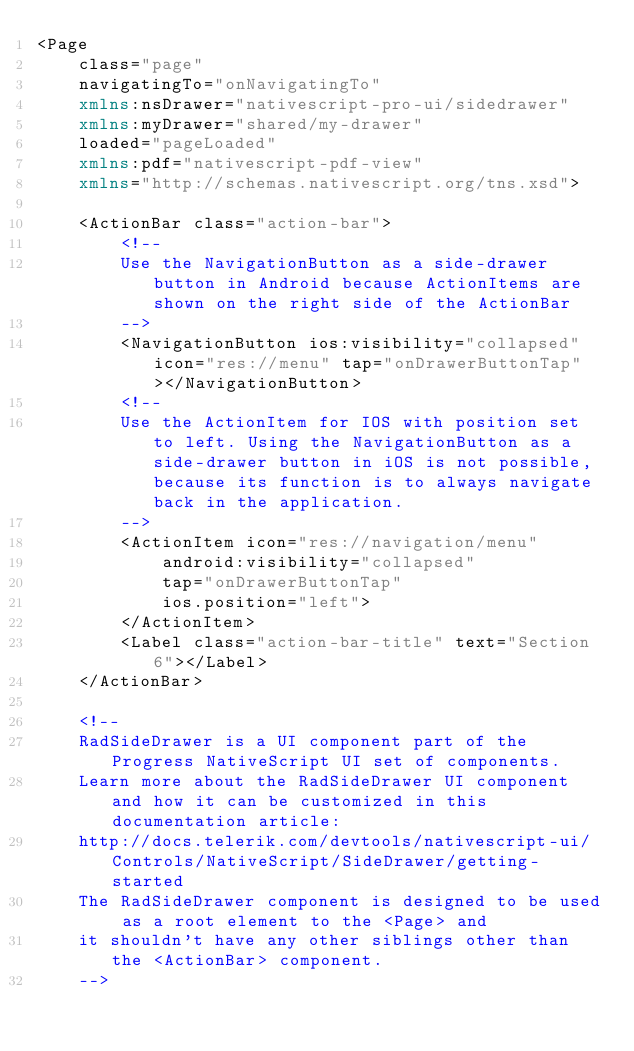<code> <loc_0><loc_0><loc_500><loc_500><_XML_><Page
    class="page"
    navigatingTo="onNavigatingTo"  
    xmlns:nsDrawer="nativescript-pro-ui/sidedrawer"
    xmlns:myDrawer="shared/my-drawer"
    loaded="pageLoaded"
    xmlns:pdf="nativescript-pdf-view"
    xmlns="http://schemas.nativescript.org/tns.xsd">

    <ActionBar class="action-bar">
        <!-- 
        Use the NavigationButton as a side-drawer button in Android because ActionItems are shown on the right side of the ActionBar
        -->
        <NavigationButton ios:visibility="collapsed" icon="res://menu" tap="onDrawerButtonTap"></NavigationButton>
        <!-- 
        Use the ActionItem for IOS with position set to left. Using the NavigationButton as a side-drawer button in iOS is not possible, because its function is to always navigate back in the application.
        -->
        <ActionItem icon="res://navigation/menu" 
            android:visibility="collapsed" 
            tap="onDrawerButtonTap"
            ios.position="left">
        </ActionItem>
        <Label class="action-bar-title" text="Section 6"></Label>
    </ActionBar>

    <!--
    RadSideDrawer is a UI component part of the Progress NativeScript UI set of components.
    Learn more about the RadSideDrawer UI component and how it can be customized in this documentation article:
    http://docs.telerik.com/devtools/nativescript-ui/Controls/NativeScript/SideDrawer/getting-started
    The RadSideDrawer component is designed to be used as a root element to the <Page> and
    it shouldn't have any other siblings other than the <ActionBar> component.
    --></code> 